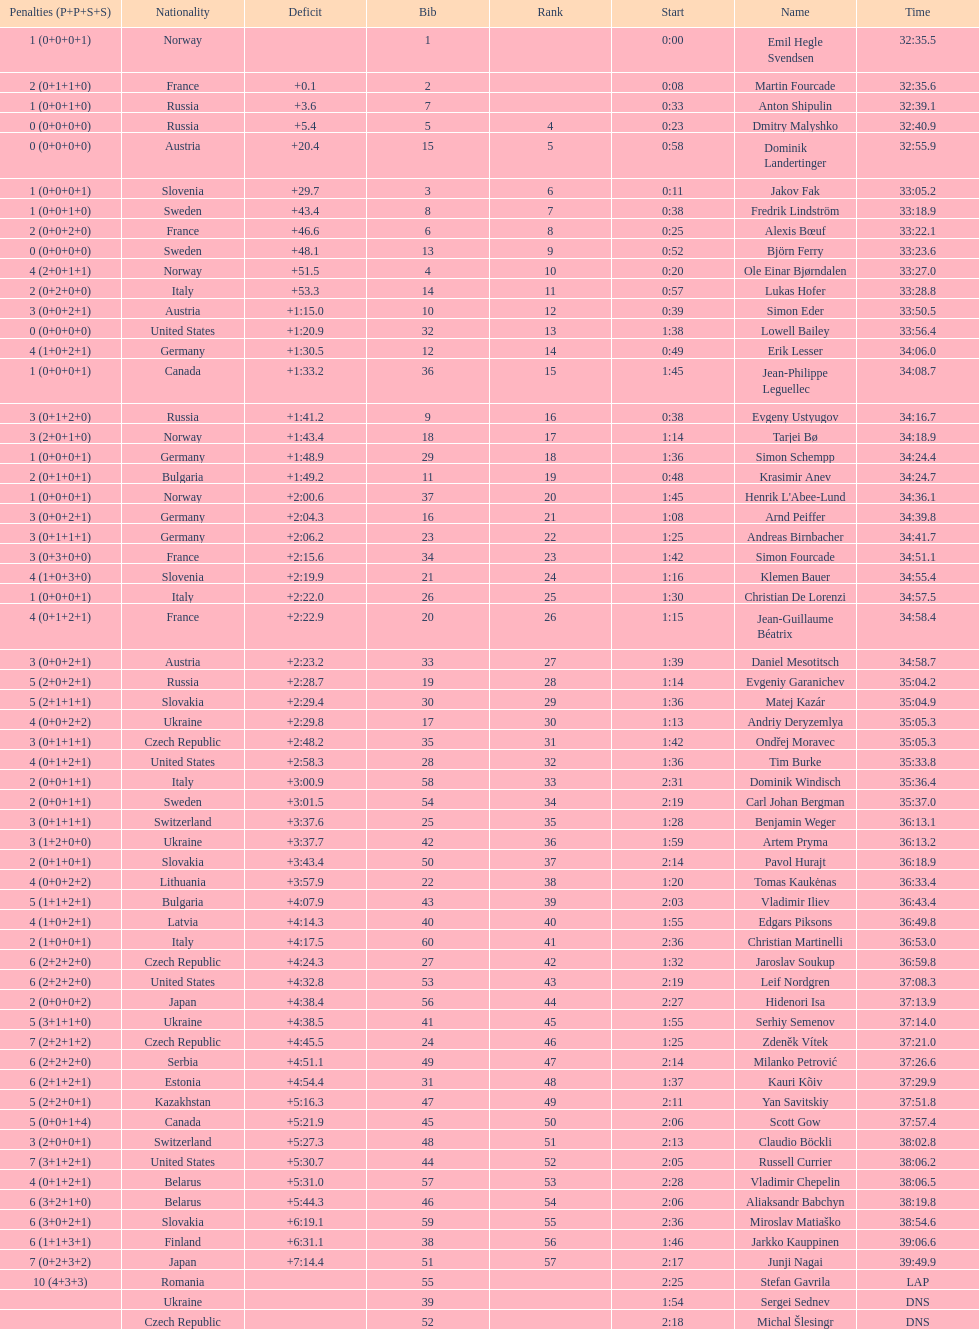Parse the full table. {'header': ['Penalties (P+P+S+S)', 'Nationality', 'Deficit', 'Bib', 'Rank', 'Start', 'Name', 'Time'], 'rows': [['1 (0+0+0+1)', 'Norway', '', '1', '', '0:00', 'Emil Hegle Svendsen', '32:35.5'], ['2 (0+1+1+0)', 'France', '+0.1', '2', '', '0:08', 'Martin Fourcade', '32:35.6'], ['1 (0+0+1+0)', 'Russia', '+3.6', '7', '', '0:33', 'Anton Shipulin', '32:39.1'], ['0 (0+0+0+0)', 'Russia', '+5.4', '5', '4', '0:23', 'Dmitry Malyshko', '32:40.9'], ['0 (0+0+0+0)', 'Austria', '+20.4', '15', '5', '0:58', 'Dominik Landertinger', '32:55.9'], ['1 (0+0+0+1)', 'Slovenia', '+29.7', '3', '6', '0:11', 'Jakov Fak', '33:05.2'], ['1 (0+0+1+0)', 'Sweden', '+43.4', '8', '7', '0:38', 'Fredrik Lindström', '33:18.9'], ['2 (0+0+2+0)', 'France', '+46.6', '6', '8', '0:25', 'Alexis Bœuf', '33:22.1'], ['0 (0+0+0+0)', 'Sweden', '+48.1', '13', '9', '0:52', 'Björn Ferry', '33:23.6'], ['4 (2+0+1+1)', 'Norway', '+51.5', '4', '10', '0:20', 'Ole Einar Bjørndalen', '33:27.0'], ['2 (0+2+0+0)', 'Italy', '+53.3', '14', '11', '0:57', 'Lukas Hofer', '33:28.8'], ['3 (0+0+2+1)', 'Austria', '+1:15.0', '10', '12', '0:39', 'Simon Eder', '33:50.5'], ['0 (0+0+0+0)', 'United States', '+1:20.9', '32', '13', '1:38', 'Lowell Bailey', '33:56.4'], ['4 (1+0+2+1)', 'Germany', '+1:30.5', '12', '14', '0:49', 'Erik Lesser', '34:06.0'], ['1 (0+0+0+1)', 'Canada', '+1:33.2', '36', '15', '1:45', 'Jean-Philippe Leguellec', '34:08.7'], ['3 (0+1+2+0)', 'Russia', '+1:41.2', '9', '16', '0:38', 'Evgeny Ustyugov', '34:16.7'], ['3 (2+0+1+0)', 'Norway', '+1:43.4', '18', '17', '1:14', 'Tarjei Bø', '34:18.9'], ['1 (0+0+0+1)', 'Germany', '+1:48.9', '29', '18', '1:36', 'Simon Schempp', '34:24.4'], ['2 (0+1+0+1)', 'Bulgaria', '+1:49.2', '11', '19', '0:48', 'Krasimir Anev', '34:24.7'], ['1 (0+0+0+1)', 'Norway', '+2:00.6', '37', '20', '1:45', "Henrik L'Abee-Lund", '34:36.1'], ['3 (0+0+2+1)', 'Germany', '+2:04.3', '16', '21', '1:08', 'Arnd Peiffer', '34:39.8'], ['3 (0+1+1+1)', 'Germany', '+2:06.2', '23', '22', '1:25', 'Andreas Birnbacher', '34:41.7'], ['3 (0+3+0+0)', 'France', '+2:15.6', '34', '23', '1:42', 'Simon Fourcade', '34:51.1'], ['4 (1+0+3+0)', 'Slovenia', '+2:19.9', '21', '24', '1:16', 'Klemen Bauer', '34:55.4'], ['1 (0+0+0+1)', 'Italy', '+2:22.0', '26', '25', '1:30', 'Christian De Lorenzi', '34:57.5'], ['4 (0+1+2+1)', 'France', '+2:22.9', '20', '26', '1:15', 'Jean-Guillaume Béatrix', '34:58.4'], ['3 (0+0+2+1)', 'Austria', '+2:23.2', '33', '27', '1:39', 'Daniel Mesotitsch', '34:58.7'], ['5 (2+0+2+1)', 'Russia', '+2:28.7', '19', '28', '1:14', 'Evgeniy Garanichev', '35:04.2'], ['5 (2+1+1+1)', 'Slovakia', '+2:29.4', '30', '29', '1:36', 'Matej Kazár', '35:04.9'], ['4 (0+0+2+2)', 'Ukraine', '+2:29.8', '17', '30', '1:13', 'Andriy Deryzemlya', '35:05.3'], ['3 (0+1+1+1)', 'Czech Republic', '+2:48.2', '35', '31', '1:42', 'Ondřej Moravec', '35:05.3'], ['4 (0+1+2+1)', 'United States', '+2:58.3', '28', '32', '1:36', 'Tim Burke', '35:33.8'], ['2 (0+0+1+1)', 'Italy', '+3:00.9', '58', '33', '2:31', 'Dominik Windisch', '35:36.4'], ['2 (0+0+1+1)', 'Sweden', '+3:01.5', '54', '34', '2:19', 'Carl Johan Bergman', '35:37.0'], ['3 (0+1+1+1)', 'Switzerland', '+3:37.6', '25', '35', '1:28', 'Benjamin Weger', '36:13.1'], ['3 (1+2+0+0)', 'Ukraine', '+3:37.7', '42', '36', '1:59', 'Artem Pryma', '36:13.2'], ['2 (0+1+0+1)', 'Slovakia', '+3:43.4', '50', '37', '2:14', 'Pavol Hurajt', '36:18.9'], ['4 (0+0+2+2)', 'Lithuania', '+3:57.9', '22', '38', '1:20', 'Tomas Kaukėnas', '36:33.4'], ['5 (1+1+2+1)', 'Bulgaria', '+4:07.9', '43', '39', '2:03', 'Vladimir Iliev', '36:43.4'], ['4 (1+0+2+1)', 'Latvia', '+4:14.3', '40', '40', '1:55', 'Edgars Piksons', '36:49.8'], ['2 (1+0+0+1)', 'Italy', '+4:17.5', '60', '41', '2:36', 'Christian Martinelli', '36:53.0'], ['6 (2+2+2+0)', 'Czech Republic', '+4:24.3', '27', '42', '1:32', 'Jaroslav Soukup', '36:59.8'], ['6 (2+2+2+0)', 'United States', '+4:32.8', '53', '43', '2:19', 'Leif Nordgren', '37:08.3'], ['2 (0+0+0+2)', 'Japan', '+4:38.4', '56', '44', '2:27', 'Hidenori Isa', '37:13.9'], ['5 (3+1+1+0)', 'Ukraine', '+4:38.5', '41', '45', '1:55', 'Serhiy Semenov', '37:14.0'], ['7 (2+2+1+2)', 'Czech Republic', '+4:45.5', '24', '46', '1:25', 'Zdeněk Vítek', '37:21.0'], ['6 (2+2+2+0)', 'Serbia', '+4:51.1', '49', '47', '2:14', 'Milanko Petrović', '37:26.6'], ['6 (2+1+2+1)', 'Estonia', '+4:54.4', '31', '48', '1:37', 'Kauri Kõiv', '37:29.9'], ['5 (2+2+0+1)', 'Kazakhstan', '+5:16.3', '47', '49', '2:11', 'Yan Savitskiy', '37:51.8'], ['5 (0+0+1+4)', 'Canada', '+5:21.9', '45', '50', '2:06', 'Scott Gow', '37:57.4'], ['3 (2+0+0+1)', 'Switzerland', '+5:27.3', '48', '51', '2:13', 'Claudio Böckli', '38:02.8'], ['7 (3+1+2+1)', 'United States', '+5:30.7', '44', '52', '2:05', 'Russell Currier', '38:06.2'], ['4 (0+1+2+1)', 'Belarus', '+5:31.0', '57', '53', '2:28', 'Vladimir Chepelin', '38:06.5'], ['6 (3+2+1+0)', 'Belarus', '+5:44.3', '46', '54', '2:06', 'Aliaksandr Babchyn', '38:19.8'], ['6 (3+0+2+1)', 'Slovakia', '+6:19.1', '59', '55', '2:36', 'Miroslav Matiaško', '38:54.6'], ['6 (1+1+3+1)', 'Finland', '+6:31.1', '38', '56', '1:46', 'Jarkko Kauppinen', '39:06.6'], ['7 (0+2+3+2)', 'Japan', '+7:14.4', '51', '57', '2:17', 'Junji Nagai', '39:49.9'], ['10 (4+3+3)', 'Romania', '', '55', '', '2:25', 'Stefan Gavrila', 'LAP'], ['', 'Ukraine', '', '39', '', '1:54', 'Sergei Sednev', 'DNS'], ['', 'Czech Republic', '', '52', '', '2:18', 'Michal Šlesingr', 'DNS']]} Who is the top ranked runner of sweden? Fredrik Lindström. 